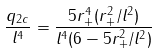<formula> <loc_0><loc_0><loc_500><loc_500>\frac { q _ { 2 c } } { l ^ { 4 } } = \frac { 5 r _ { + } ^ { 4 } ( r _ { + } ^ { 2 } / l ^ { 2 } ) } { l ^ { 4 } ( 6 - 5 r _ { + } ^ { 2 } / l ^ { 2 } ) }</formula> 